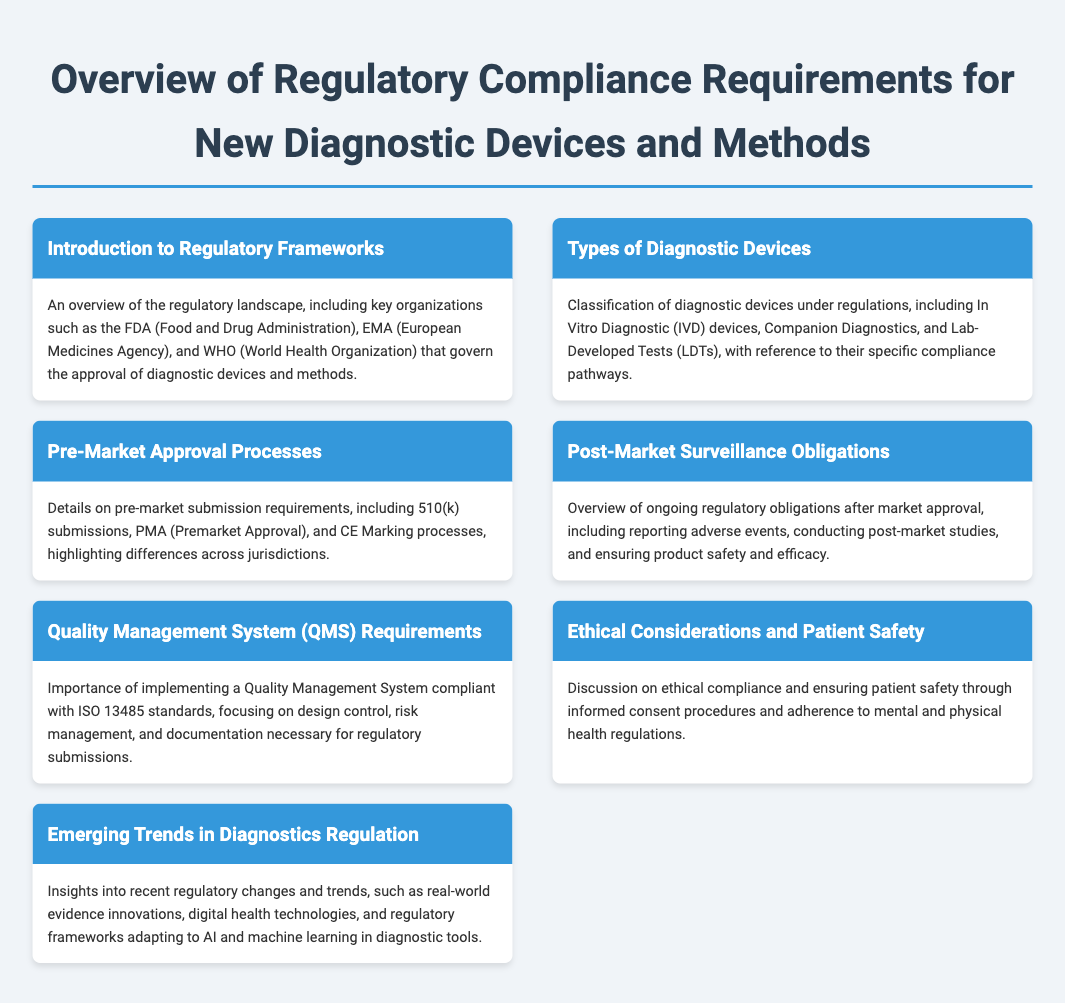what agency is mentioned for regulatory approval? The document mentions key organizations such as the FDA (Food and Drug Administration), the EMA (European Medicines Agency), and the WHO (World Health Organization) governing approval.
Answer: FDA what does IVD stand for? The abbreviation IVD is mentioned in the context of types of diagnostic devices, referring to In Vitro Diagnostic devices.
Answer: In Vitro Diagnostic what is a key requirement for pre-market approval? The document discusses 510(k) submissions as an important aspect of pre-market approval processes.
Answer: 510(k) what standard is essential for Quality Management Systems? The document states that implementing a Quality Management System compliant with ISO 13485 standards is important.
Answer: ISO 13485 what type of studies must be conducted post-market? The document requires conducting post-market studies as part of ongoing obligations after market approval.
Answer: Post-market studies what are ethical considerations in diagnostics? Ethical compliance is discussed in the document, particularly the importance of informed consent procedures and patient safety.
Answer: Informed consent how are emerging trends in diagnostics addressed? The document highlights insights into recent regulatory changes and trends specific to diagnostics regulation.
Answer: Regulatory changes how many types of diagnostic devices are classified? The document categorizes diagnostic devices under multiple classifications but does not state a specific number, focusing instead on types like IVDs and LDTs.
Answer: Multiple classifications 